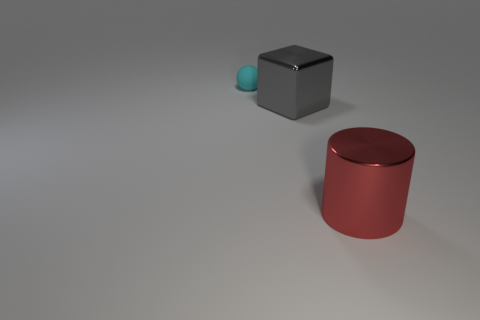Can you tell me about the lighting in the image? Certainly! The lighting in the image appears to be coming from the upper left side, casting soft shadows to the right of the objects, which suggests a diffuse light source creating a calm and even ambiance. 